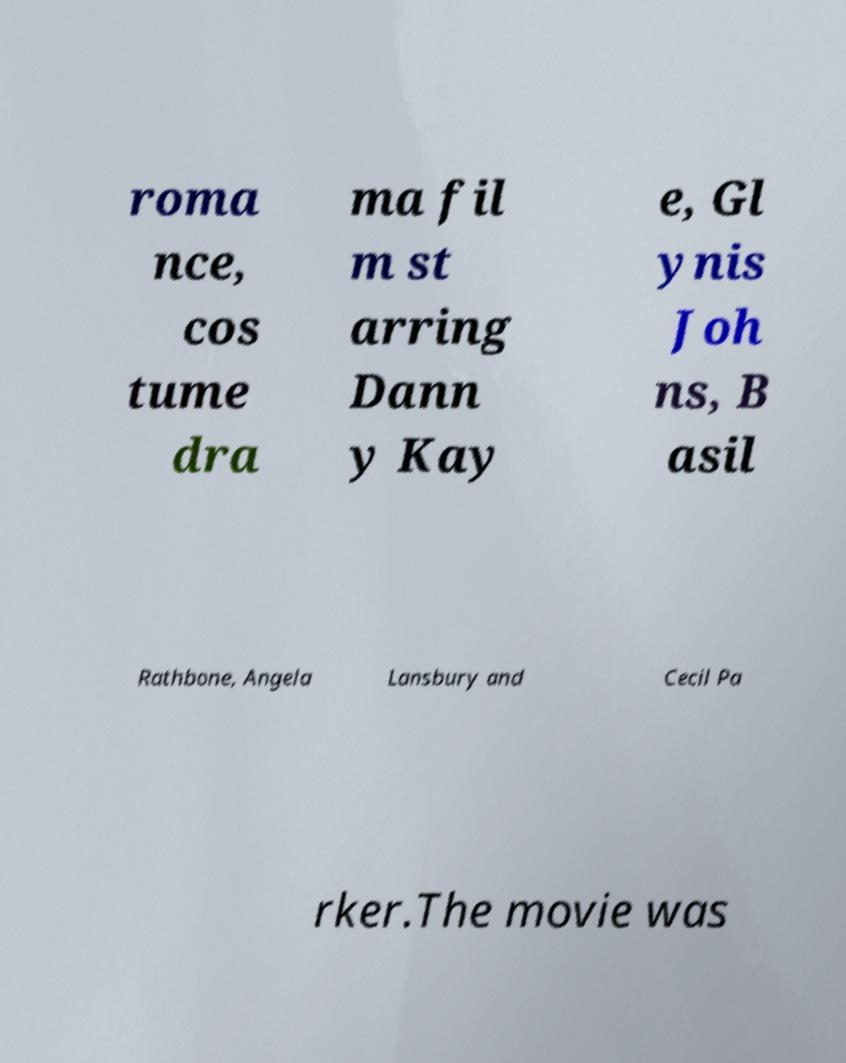Can you accurately transcribe the text from the provided image for me? roma nce, cos tume dra ma fil m st arring Dann y Kay e, Gl ynis Joh ns, B asil Rathbone, Angela Lansbury and Cecil Pa rker.The movie was 